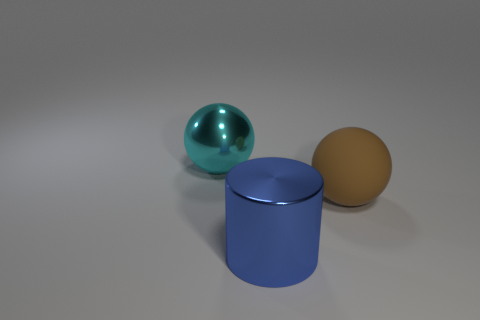Are there any other things that are the same size as the brown sphere?
Keep it short and to the point. Yes. Does the large object that is to the right of the large blue metallic cylinder have the same shape as the big blue thing?
Your answer should be very brief. No. How many objects are both right of the cyan metallic sphere and on the left side of the brown rubber sphere?
Your answer should be very brief. 1. What is the blue object made of?
Provide a succinct answer. Metal. Do the big cylinder and the large cyan ball have the same material?
Your response must be concise. Yes. There is a large metallic thing that is on the right side of the sphere that is left of the big blue metal cylinder; how many large metal things are left of it?
Give a very brief answer. 1. How many cylinders are there?
Your answer should be compact. 1. Is the number of large cylinders behind the brown sphere less than the number of balls in front of the large cylinder?
Your response must be concise. No. Is the number of brown matte things that are to the right of the large brown thing less than the number of metal things?
Offer a terse response. Yes. What is the large sphere that is on the left side of the ball right of the shiny thing behind the cylinder made of?
Offer a very short reply. Metal. 